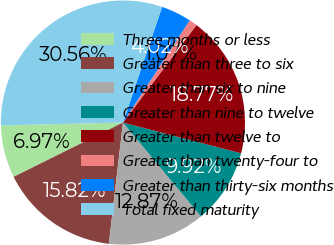<chart> <loc_0><loc_0><loc_500><loc_500><pie_chart><fcel>Three months or less<fcel>Greater than three to six<fcel>Greater than six to nine<fcel>Greater than nine to twelve<fcel>Greater than twelve to<fcel>Greater than twenty-four to<fcel>Greater than thirty-six months<fcel>Total fixed maturity<nl><fcel>6.97%<fcel>15.82%<fcel>12.87%<fcel>9.92%<fcel>18.77%<fcel>1.07%<fcel>4.02%<fcel>30.56%<nl></chart> 